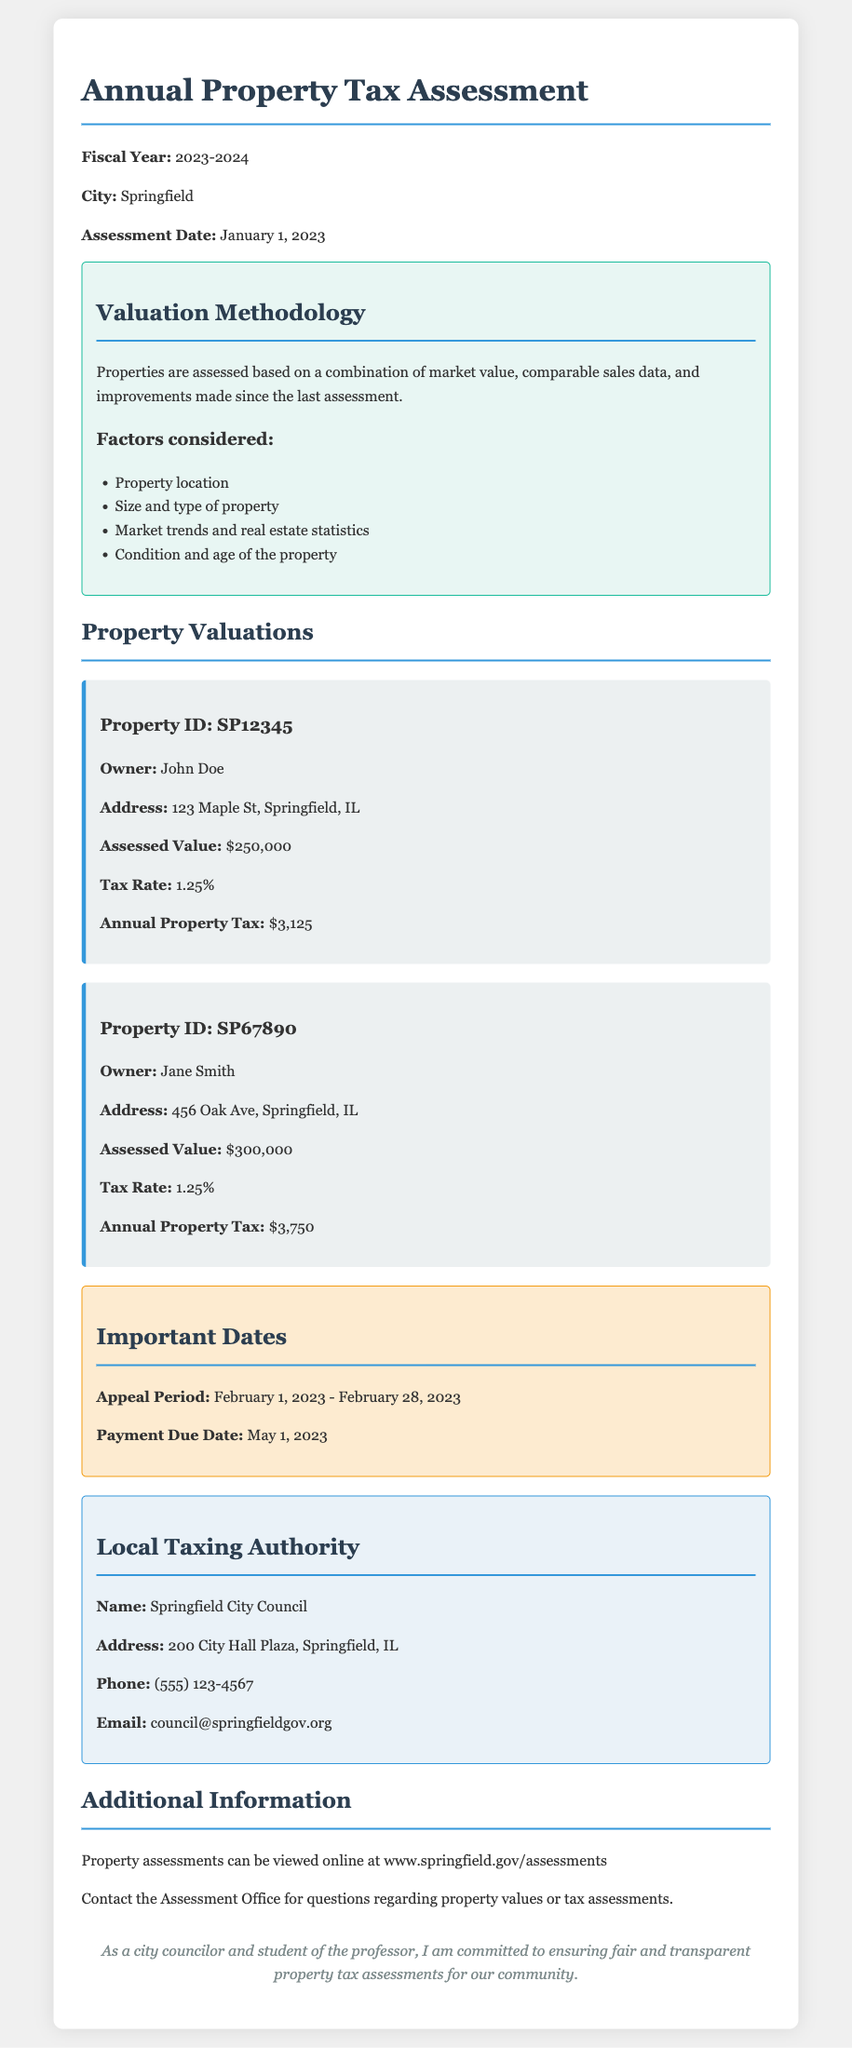What is the fiscal year for the assessment? The fiscal year is explicitly stated in the document.
Answer: 2023-2024 What is the assessment date? The assessment date is specified in the document under the relevant section.
Answer: January 1, 2023 Who is the owner of the property with ID SP67890? The owner's name is mentioned in the property detail of the document.
Answer: Jane Smith What is the assessed value of the property located at 123 Maple St? The assessed value is clearly laid out in the property valuation section.
Answer: $250,000 What is the tax rate applied to properties in this assessment? The tax rate is presented in the document as the same for both properties listed.
Answer: 1.25% What is the annual property tax for the property identified by ID SP12345? The annual property tax is computed based on the assessed value and tax rate mentioned.
Answer: $3,125 What period was designated for appeals? The appeal period is specified clearly in the document.
Answer: February 1, 2023 - February 28, 2023 What is the contact email for the Springfield City Council? The contact email is provided in the local taxing authority section of the document.
Answer: council@springfieldgov.org How can property assessments be viewed online? The document provides a web address for viewing properties.
Answer: www.springfield.gov/assessments 